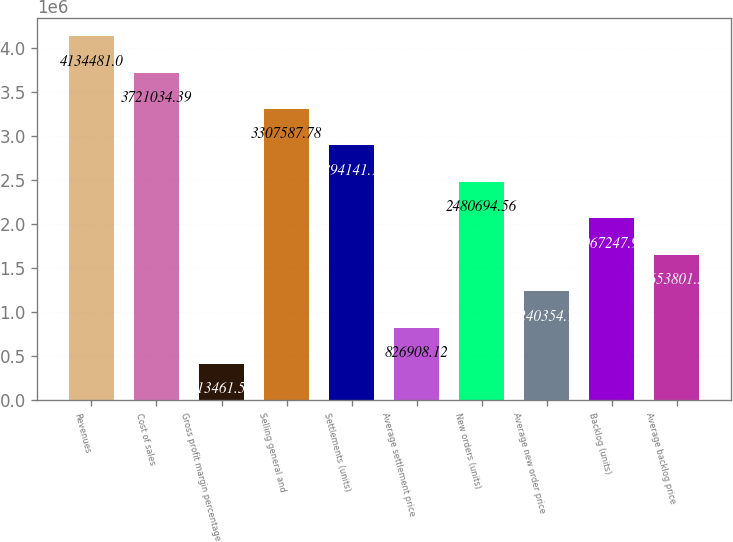Convert chart to OTSL. <chart><loc_0><loc_0><loc_500><loc_500><bar_chart><fcel>Revenues<fcel>Cost of sales<fcel>Gross profit margin percentage<fcel>Selling general and<fcel>Settlements (units)<fcel>Average settlement price<fcel>New orders (units)<fcel>Average new order price<fcel>Backlog (units)<fcel>Average backlog price<nl><fcel>4.13448e+06<fcel>3.72103e+06<fcel>413462<fcel>3.30759e+06<fcel>2.89414e+06<fcel>826908<fcel>2.48069e+06<fcel>1.24035e+06<fcel>2.06725e+06<fcel>1.6538e+06<nl></chart> 